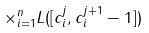<formula> <loc_0><loc_0><loc_500><loc_500>\times _ { i = 1 } ^ { n } L ( [ c ^ { j } _ { i } , c ^ { j + 1 } _ { i } - 1 ] )</formula> 